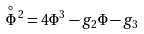<formula> <loc_0><loc_0><loc_500><loc_500>\overset { \circ } { \Phi } \, ^ { 2 } = 4 \Phi ^ { 3 } - g _ { 2 } \Phi - g _ { 3 }</formula> 